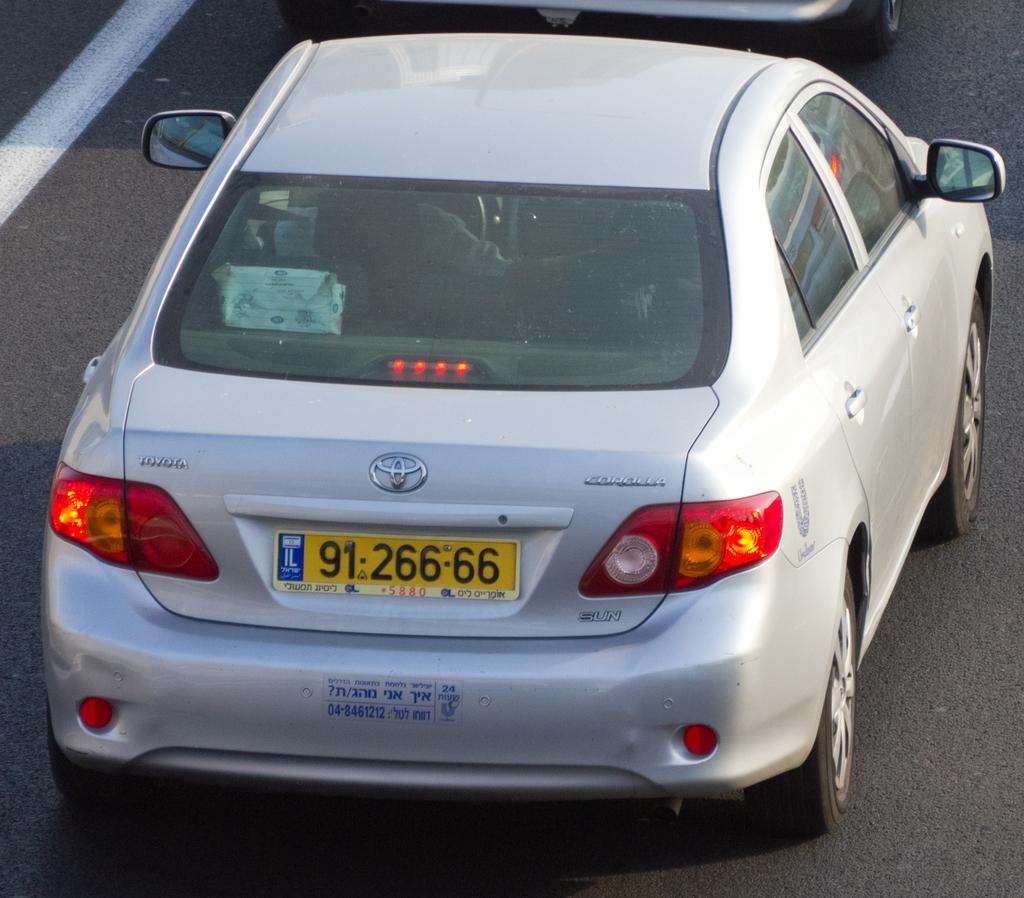Provide a one-sentence caption for the provided image. A silver Toyota Corolla has a license plate number 9126666. 